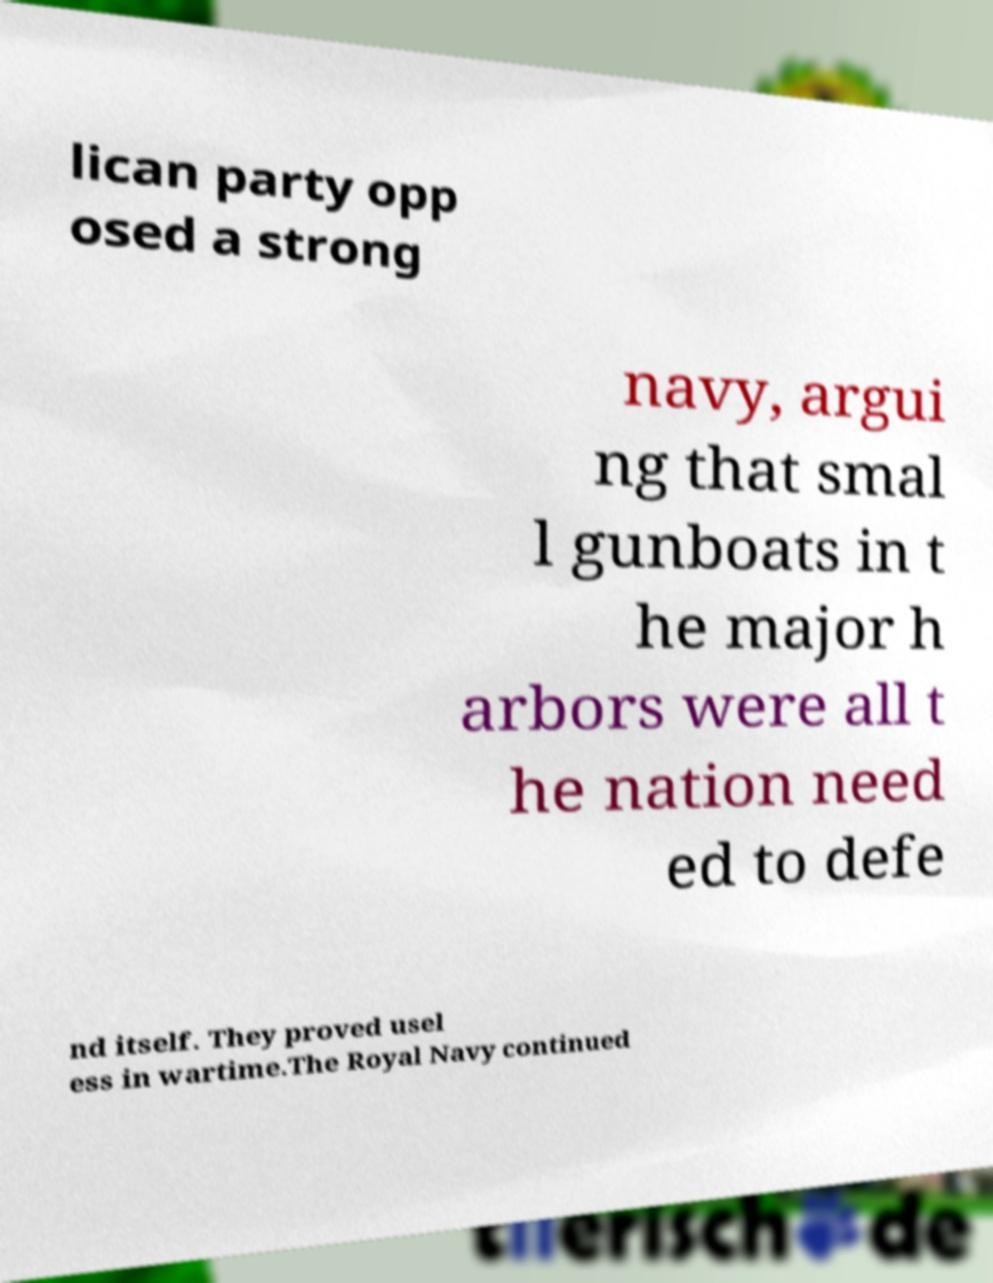There's text embedded in this image that I need extracted. Can you transcribe it verbatim? lican party opp osed a strong navy, argui ng that smal l gunboats in t he major h arbors were all t he nation need ed to defe nd itself. They proved usel ess in wartime.The Royal Navy continued 